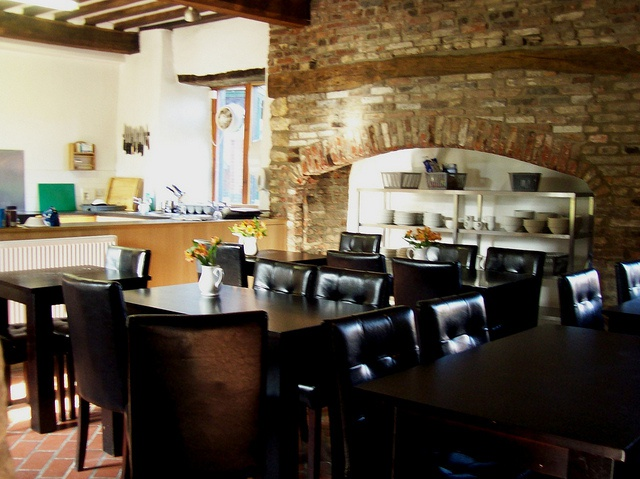Describe the objects in this image and their specific colors. I can see dining table in khaki, black, navy, and gray tones, chair in khaki, black, maroon, darkgreen, and gray tones, chair in khaki, black, maroon, and gray tones, dining table in khaki, black, darkgray, lightgray, and gray tones, and chair in khaki, black, gray, and navy tones in this image. 